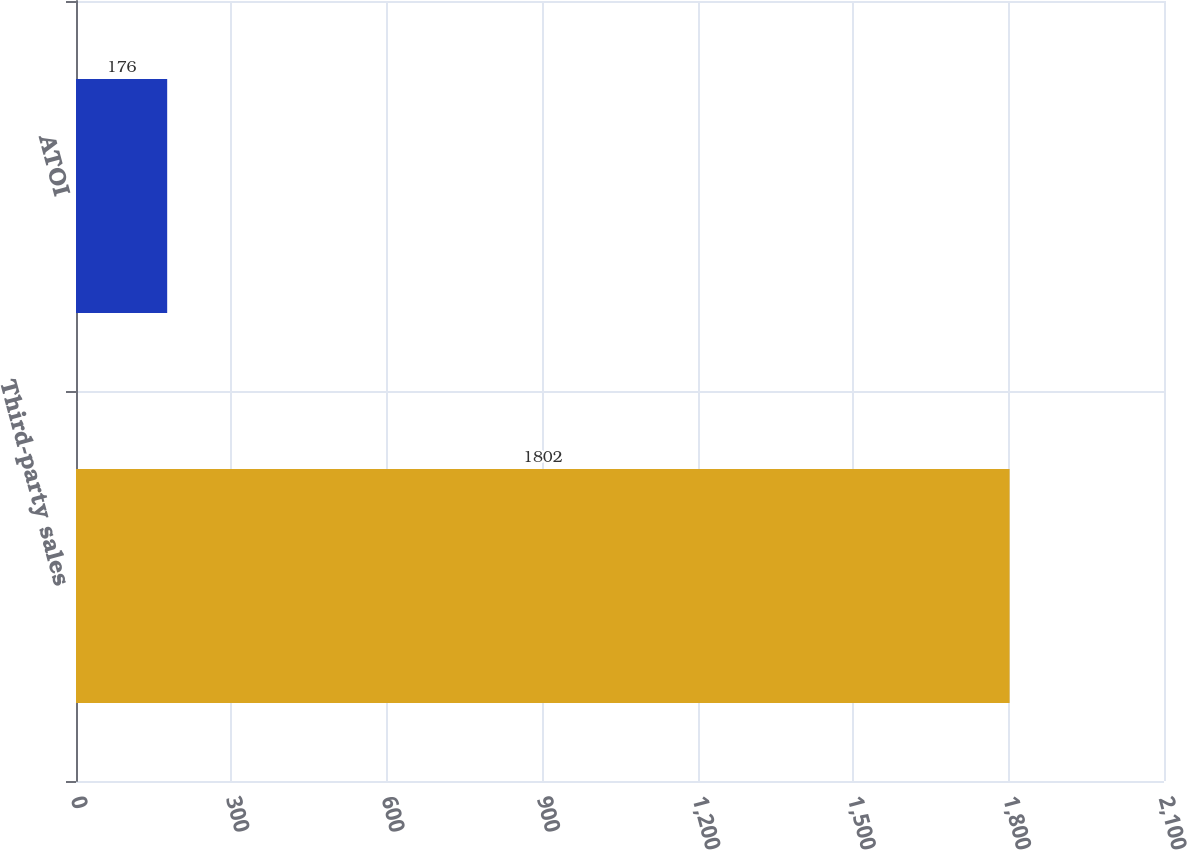Convert chart. <chart><loc_0><loc_0><loc_500><loc_500><bar_chart><fcel>Third-party sales<fcel>ATOI<nl><fcel>1802<fcel>176<nl></chart> 